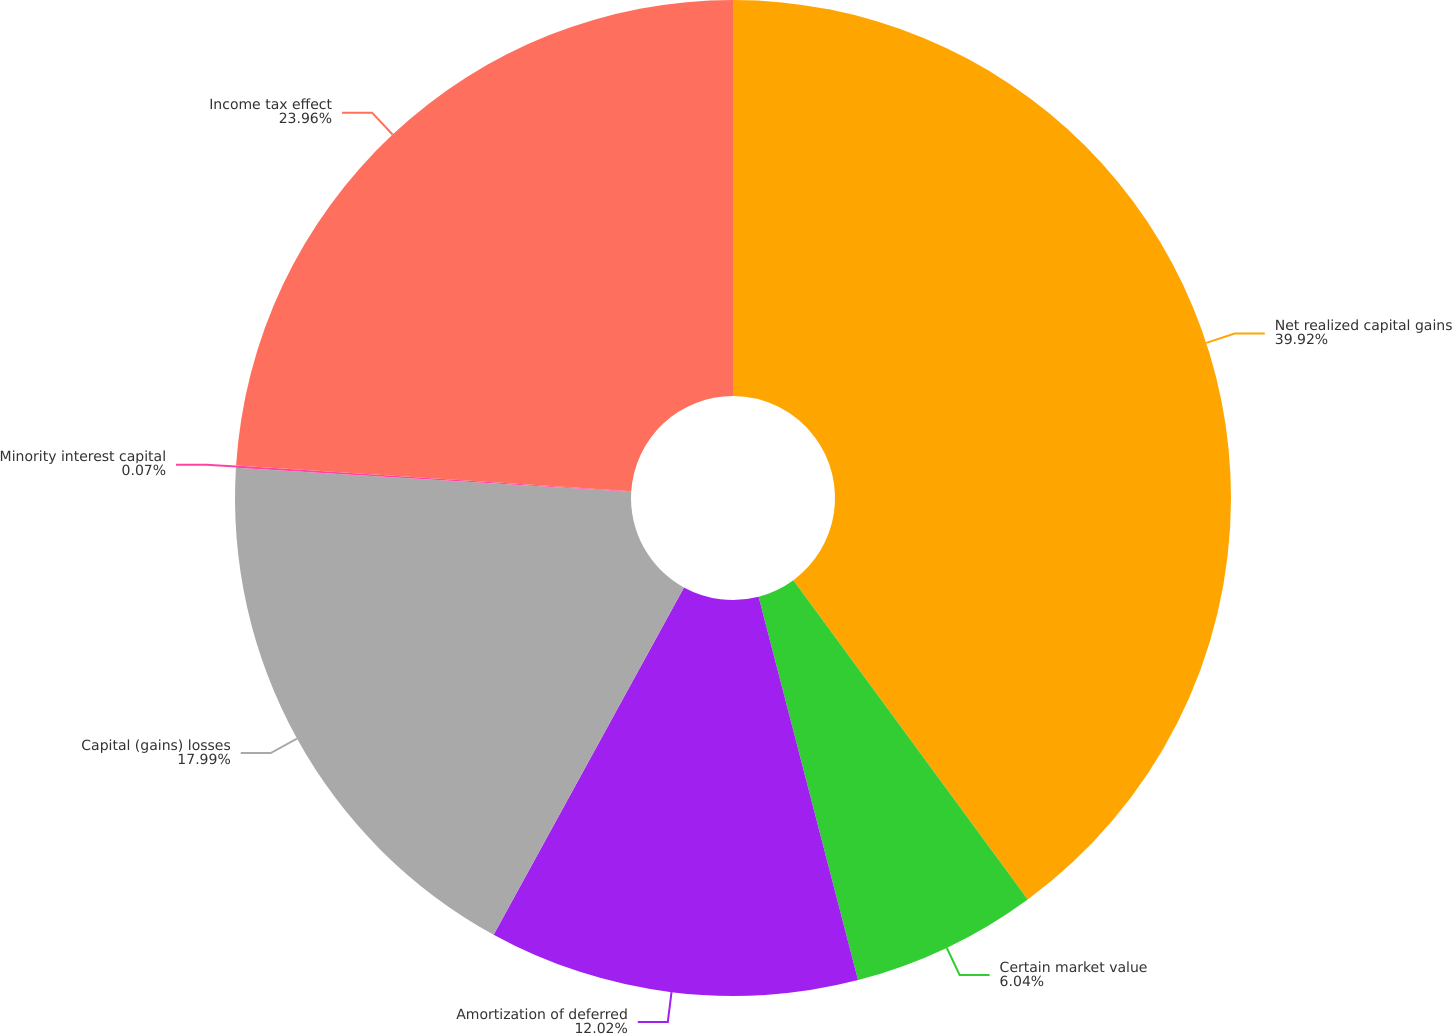Convert chart to OTSL. <chart><loc_0><loc_0><loc_500><loc_500><pie_chart><fcel>Net realized capital gains<fcel>Certain market value<fcel>Amortization of deferred<fcel>Capital (gains) losses<fcel>Minority interest capital<fcel>Income tax effect<nl><fcel>39.92%<fcel>6.04%<fcel>12.02%<fcel>17.99%<fcel>0.07%<fcel>23.96%<nl></chart> 